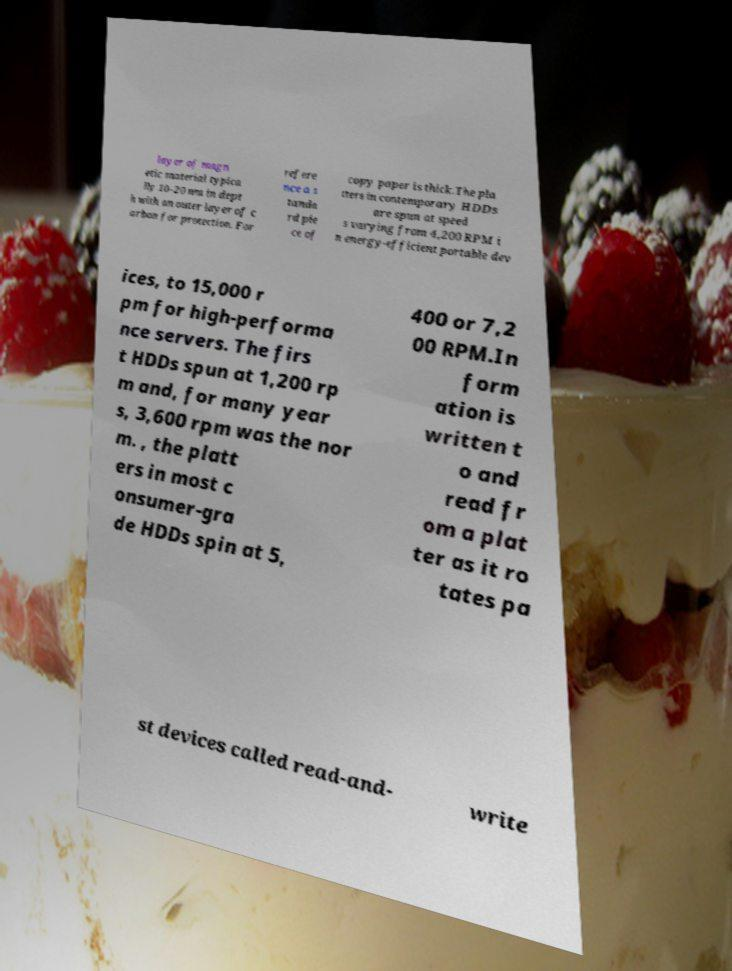Can you read and provide the text displayed in the image?This photo seems to have some interesting text. Can you extract and type it out for me? layer of magn etic material typica lly 10–20 nm in dept h with an outer layer of c arbon for protection. For refere nce a s tanda rd pie ce of copy paper is thick.The pla tters in contemporary HDDs are spun at speed s varying from 4,200 RPM i n energy-efficient portable dev ices, to 15,000 r pm for high-performa nce servers. The firs t HDDs spun at 1,200 rp m and, for many year s, 3,600 rpm was the nor m. , the platt ers in most c onsumer-gra de HDDs spin at 5, 400 or 7,2 00 RPM.In form ation is written t o and read fr om a plat ter as it ro tates pa st devices called read-and- write 